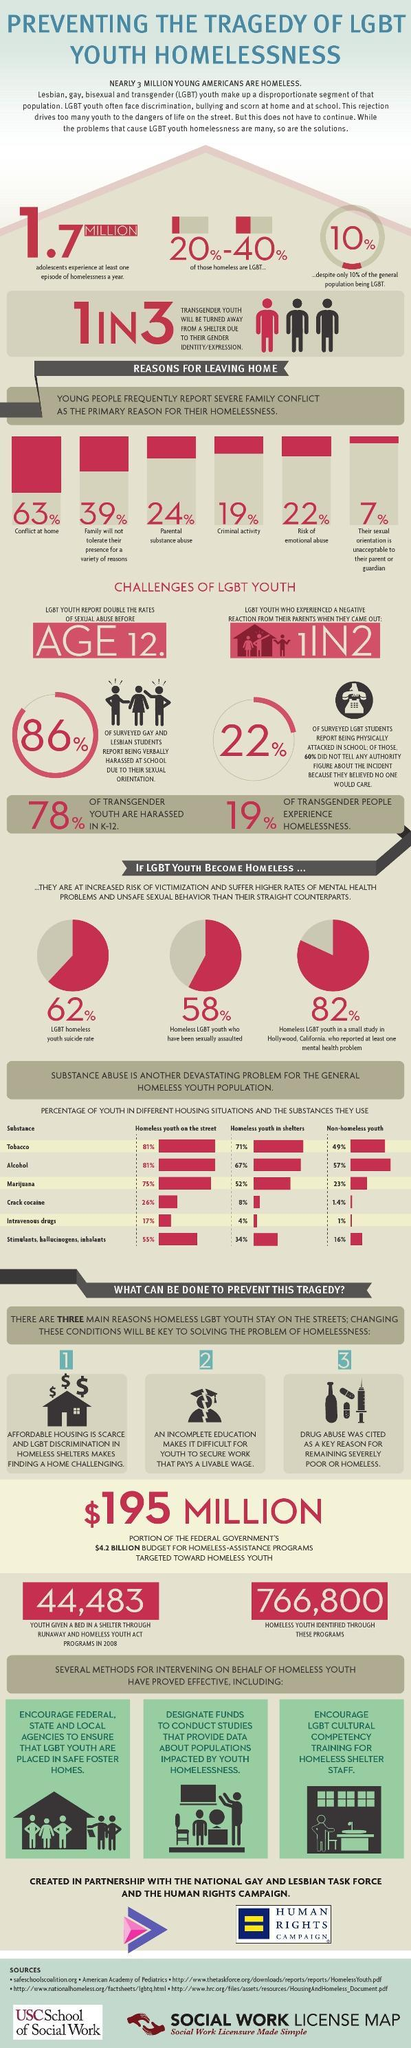What reason is cited by 19% of youth for leaving home?
Answer the question with a short phrase. Criminal activity What is the government budget for programs to aid homeless youth? 195 million What is the suicide rate in LGBT homeless youth? 62% What is a key reason for youth remaining poor or homeless? Drug abuse What makes it tough for youth to secure work with good wage? An incomplete education What percentage of youth face risk of emotional abuse? 22 